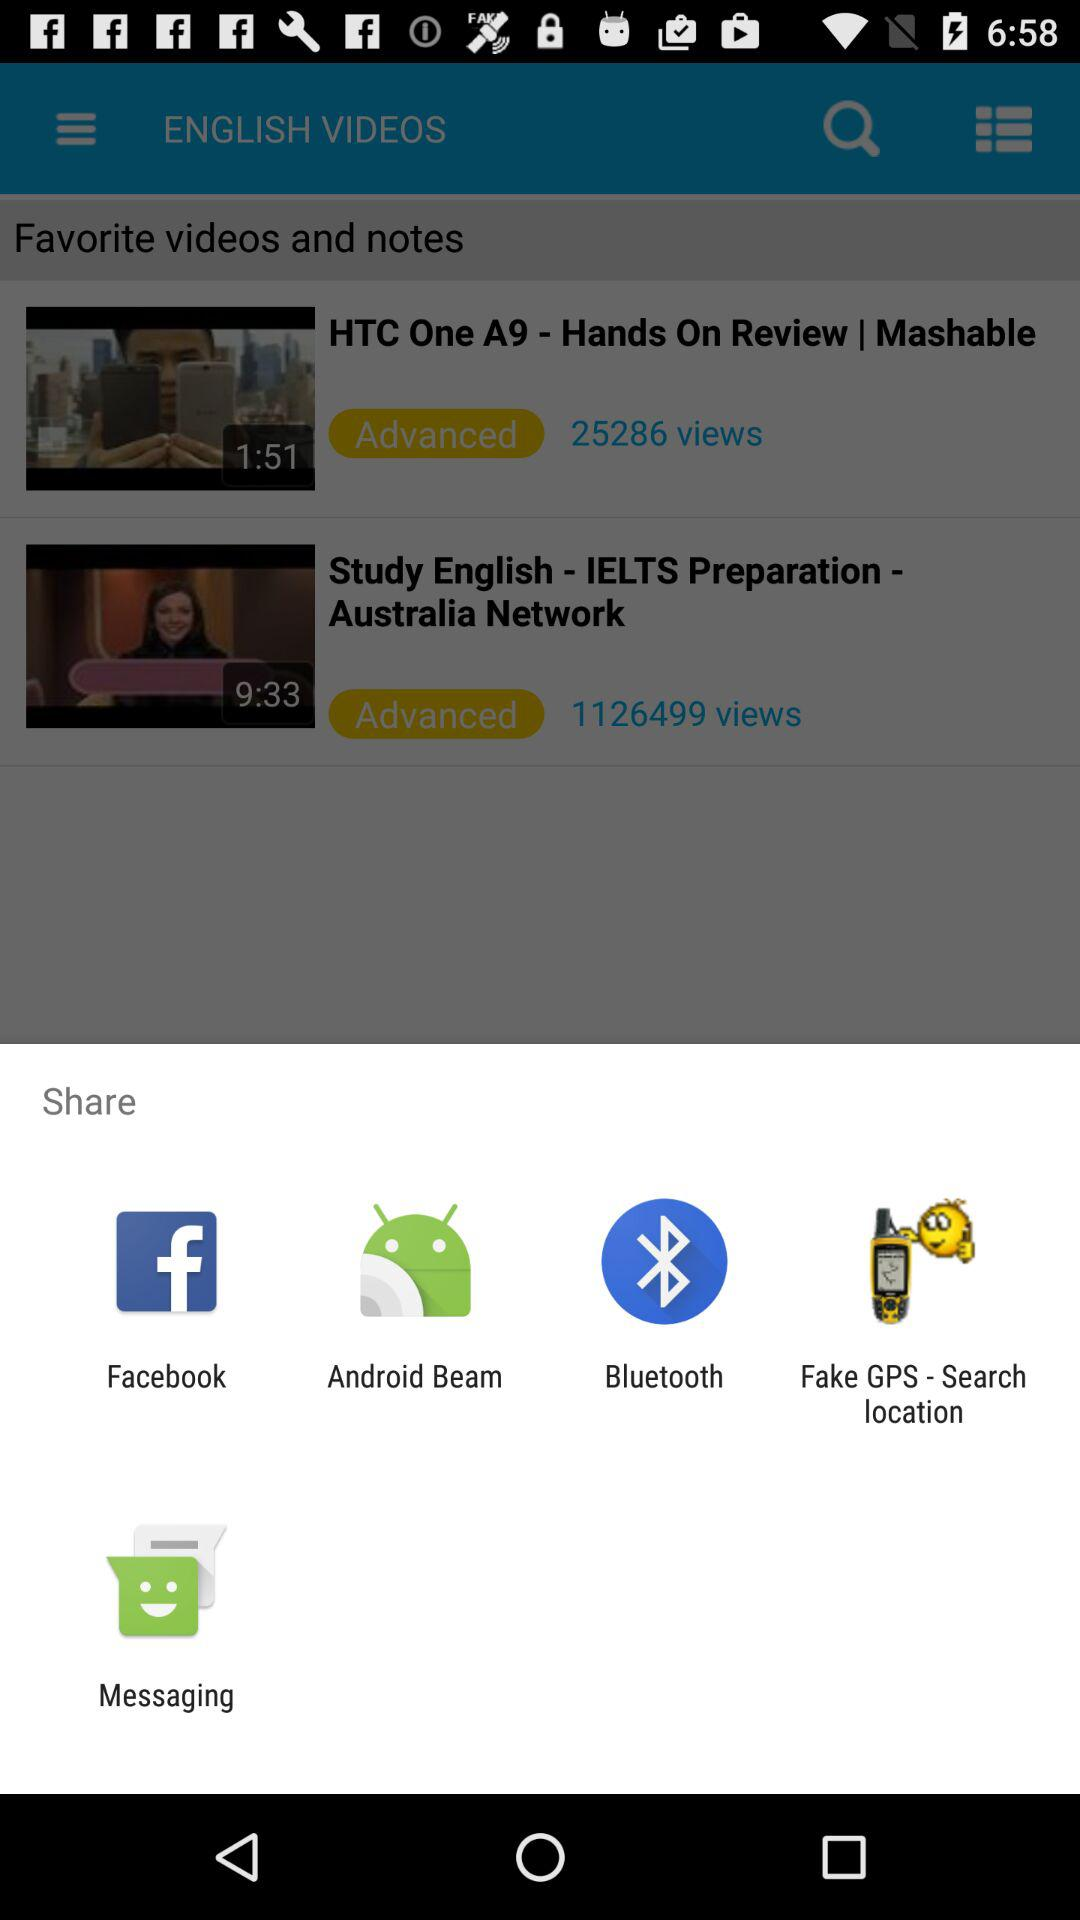Are the videos available in other languages?
When the provided information is insufficient, respond with <no answer>. <no answer> 